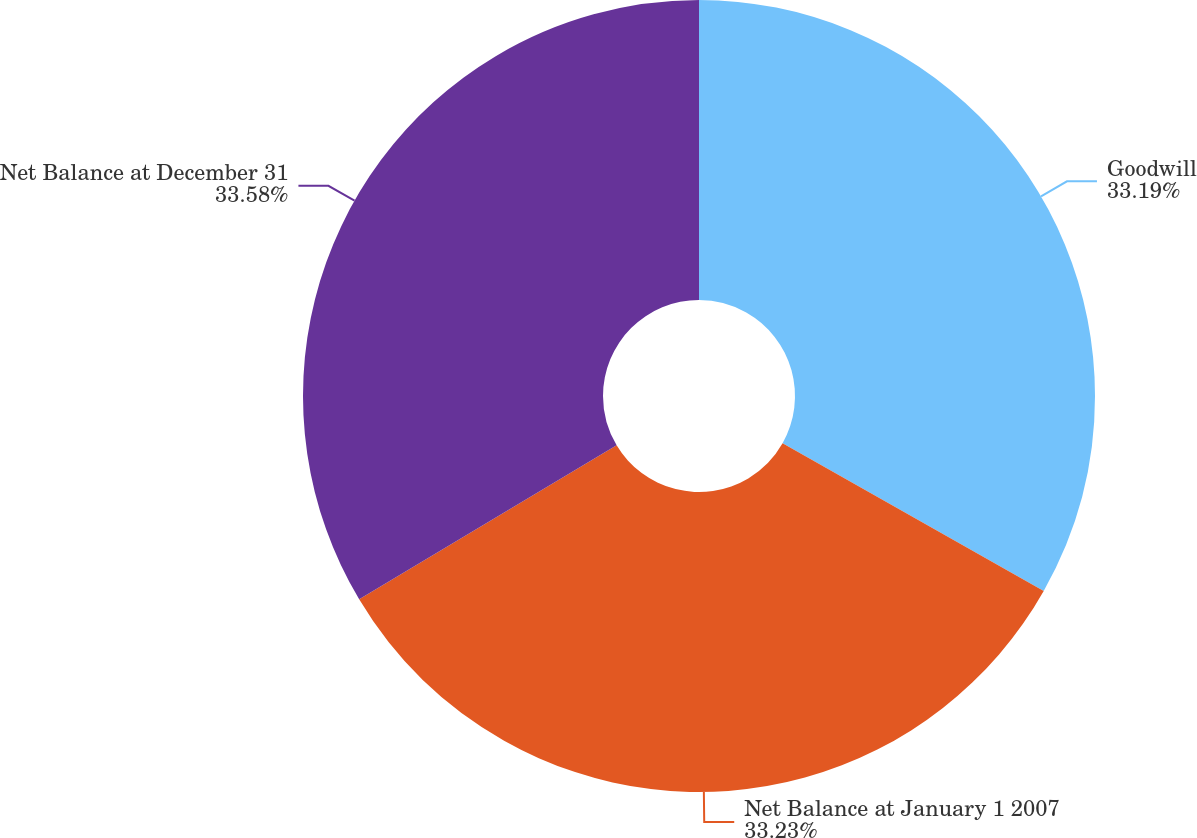Convert chart. <chart><loc_0><loc_0><loc_500><loc_500><pie_chart><fcel>Goodwill<fcel>Net Balance at January 1 2007<fcel>Net Balance at December 31<nl><fcel>33.19%<fcel>33.23%<fcel>33.58%<nl></chart> 